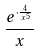<formula> <loc_0><loc_0><loc_500><loc_500>\frac { e ^ { \cdot \frac { 4 } { x ^ { 5 } } } } { x }</formula> 